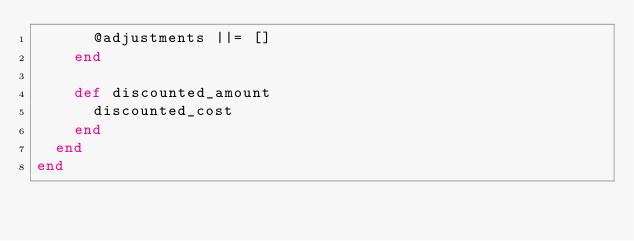<code> <loc_0><loc_0><loc_500><loc_500><_Ruby_>      @adjustments ||= []
    end

    def discounted_amount
      discounted_cost
    end
  end
end</code> 